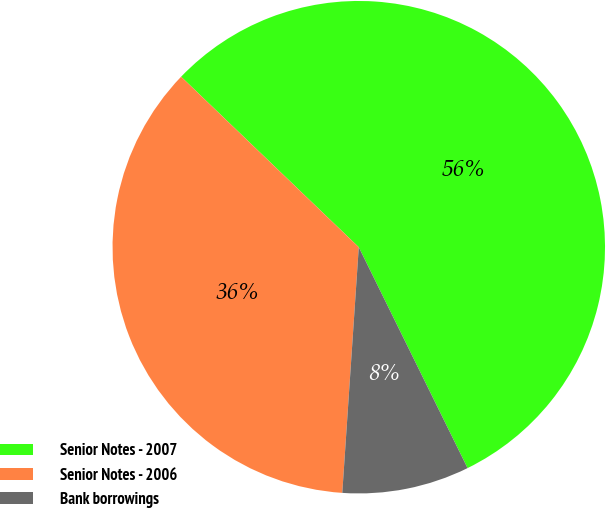Convert chart. <chart><loc_0><loc_0><loc_500><loc_500><pie_chart><fcel>Senior Notes - 2007<fcel>Senior Notes - 2006<fcel>Bank borrowings<nl><fcel>55.54%<fcel>36.1%<fcel>8.35%<nl></chart> 